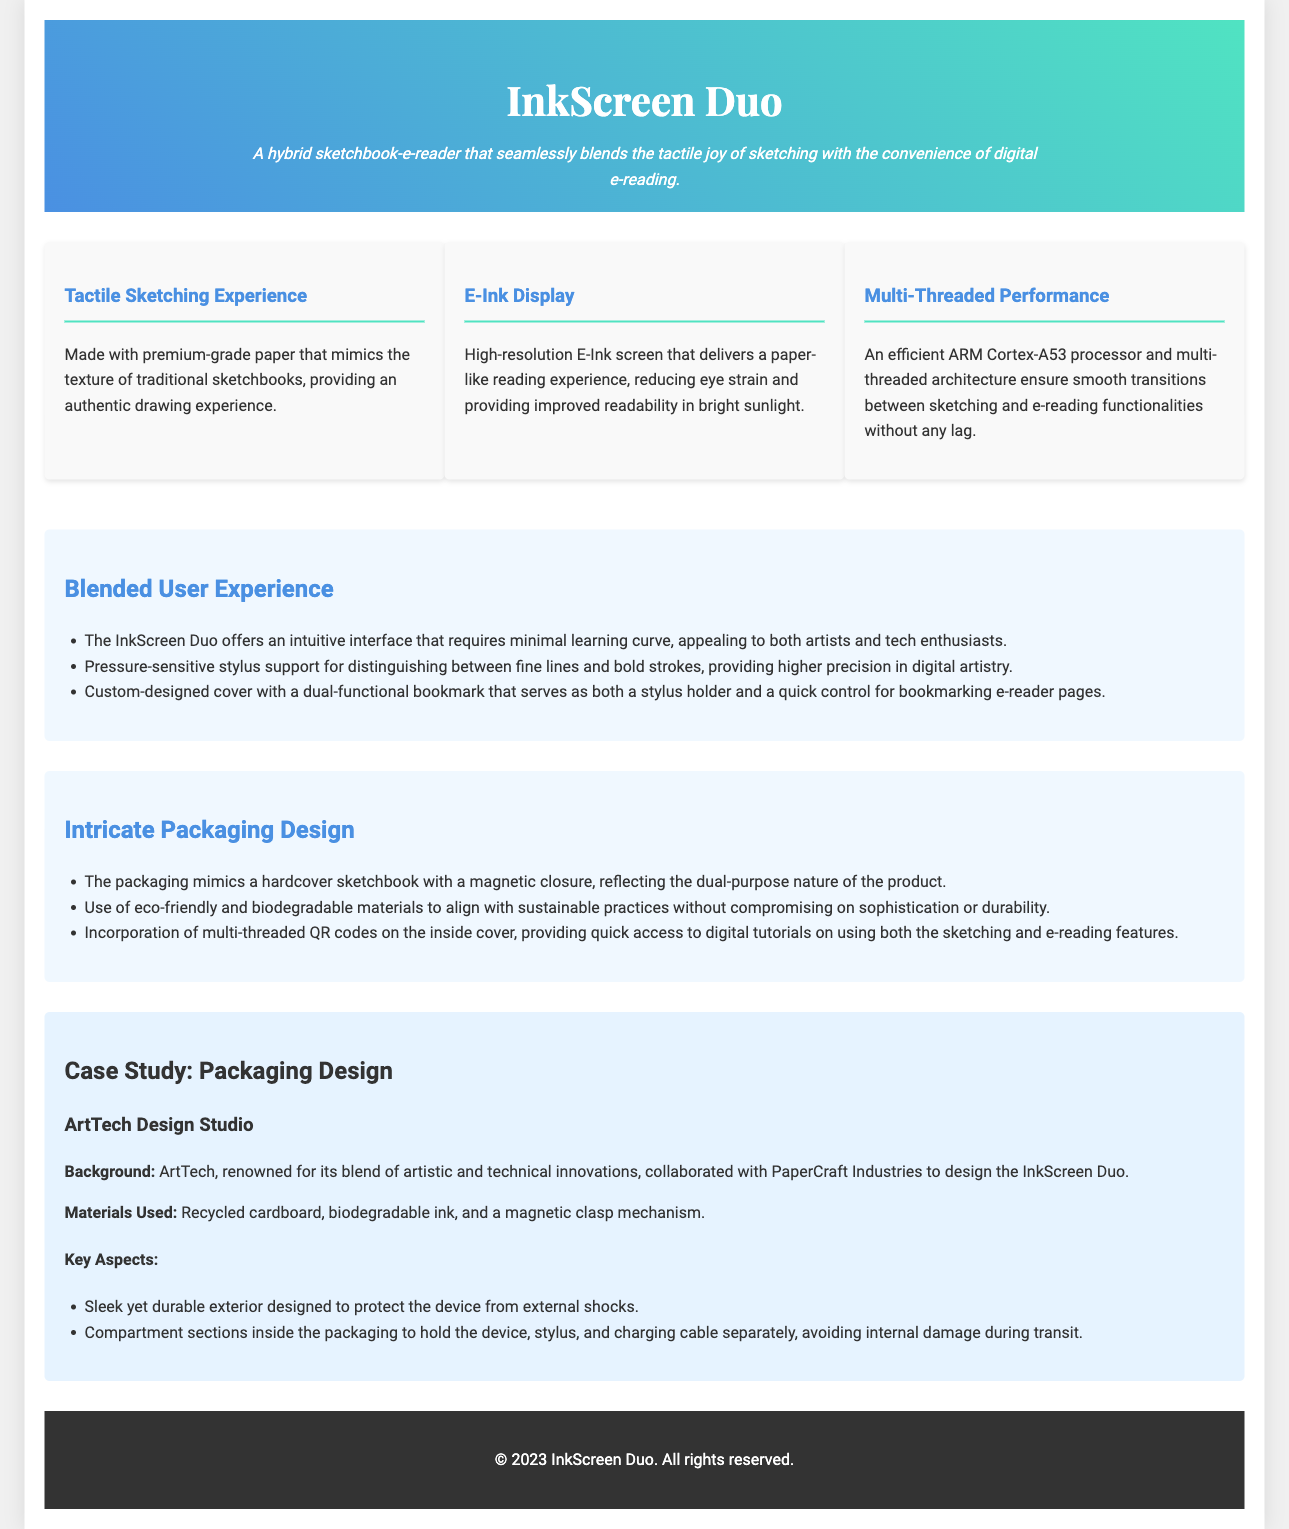what is the product name? The product name is stated at the top of the document in the header section.
Answer: InkScreen Duo what type of display does the InkScreen Duo have? This information can be found in the features section of the document.
Answer: E-Ink Display what materials were used for the packaging? This information is provided in the case study section under Materials Used about the packaging design.
Answer: Recycled cardboard, biodegradable ink, and a magnetic clasp mechanism how many key aspects are listed for the packaging design? The number of key aspects is mentioned in the case study section when discussing key features.
Answer: Two what does the packaging mimic? This detail is outlined in the design philosophy section, describing the packaging's appearance.
Answer: Hardcover sketchbook how does the packaging contribute to sustainability? This reasoning involves looking at the materials used in the packaging design.
Answer: Eco-friendly and biodegradable materials what is one feature that enhances the user experience for artists? This question requires integrating information from the user experience section about features aimed at artists.
Answer: Pressure-sensitive stylus support what is the design philosophy behind the InkScreen Duo's packaging? This question looks for an explanation found in the design philosophy section about the packaging's aesthetic and functional approach.
Answer: Intricate Packaging Design what does the case study mention about the exterior design of the packaging? Referring to the case study, this question asks about the protective aspect of the packaging design.
Answer: Sleek yet durable exterior designed to protect the device from external shocks 